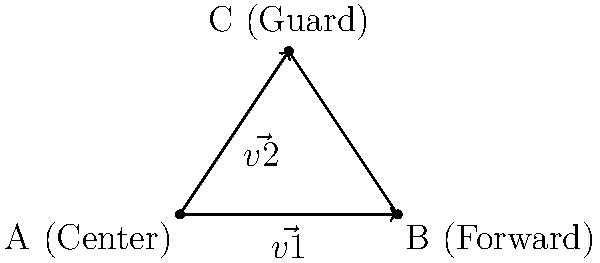In the Lakers' triangle offense, consider the positions of the center (A), forward (B), and guard (C) as shown in the diagram. If vector $\vec{v1}$ represents the direction from the center to the forward, and $\vec{v2}$ represents the direction from the center to the guard, how can we use the dot product to determine if these two vectors are perpendicular, indicating an efficient triangle formation? To determine if two vectors are perpendicular using the dot product, we follow these steps:

1. Calculate the components of $\vec{v1}$ and $\vec{v2}$:
   $\vec{v1} = B - A = (4-0, 0-0) = (4, 0)$
   $\vec{v2} = C - A = (2-0, 3-0) = (2, 3)$

2. Recall that for perpendicular vectors, their dot product equals zero:
   $\vec{v1} \cdot \vec{v2} = 0$

3. Calculate the dot product:
   $\vec{v1} \cdot \vec{v2} = (4 \times 2) + (0 \times 3) = 8 + 0 = 8$

4. Since the dot product is not zero, the vectors are not perpendicular.

5. To quantify the efficiency, we can calculate the angle between the vectors using the dot product formula:
   $\cos \theta = \frac{\vec{v1} \cdot \vec{v2}}{|\vec{v1}||\vec{v2}|}$

6. Calculate the magnitudes:
   $|\vec{v1}| = \sqrt{4^2 + 0^2} = 4$
   $|\vec{v2}| = \sqrt{2^2 + 3^2} = \sqrt{13}$

7. Substitute into the formula:
   $\cos \theta = \frac{8}{4\sqrt{13}} = \frac{2}{\sqrt{13}}$

8. Take the inverse cosine to find the angle:
   $\theta = \arccos(\frac{2}{\sqrt{13}}) \approx 56.3°$

The closer this angle is to 90°, the more efficient the triangle formation. In this case, the formation is not perfectly efficient but still creates a reasonable triangle shape for the offense.
Answer: $\theta \approx 56.3°$, not perfectly efficient but reasonable 